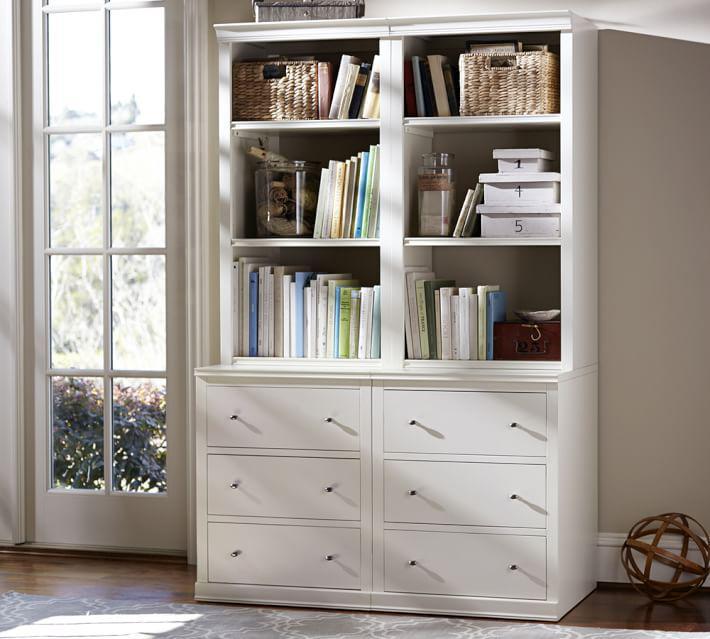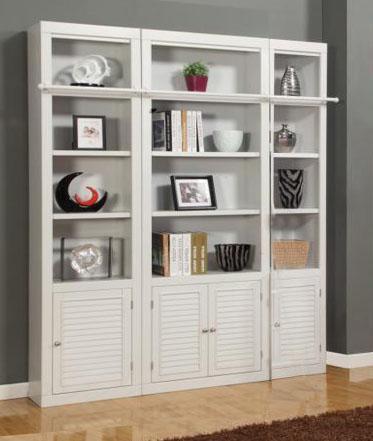The first image is the image on the left, the second image is the image on the right. Analyze the images presented: Is the assertion "One of the bookcases show is adjacent to some windows." valid? Answer yes or no. Yes. The first image is the image on the left, the second image is the image on the right. Considering the images on both sides, is "there is a white shelving unit with two whicker cubby boxes on the bottom row and a chalk board on the right" valid? Answer yes or no. No. 